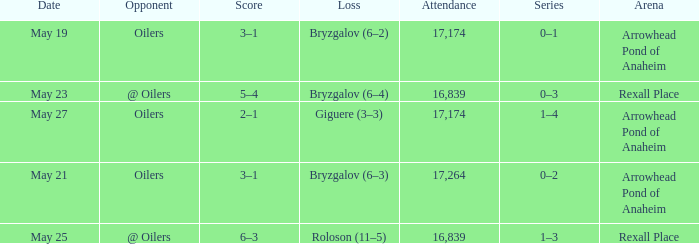Which Arena has an Opponent of @ oilers, and a Date of may 25? Rexall Place. 